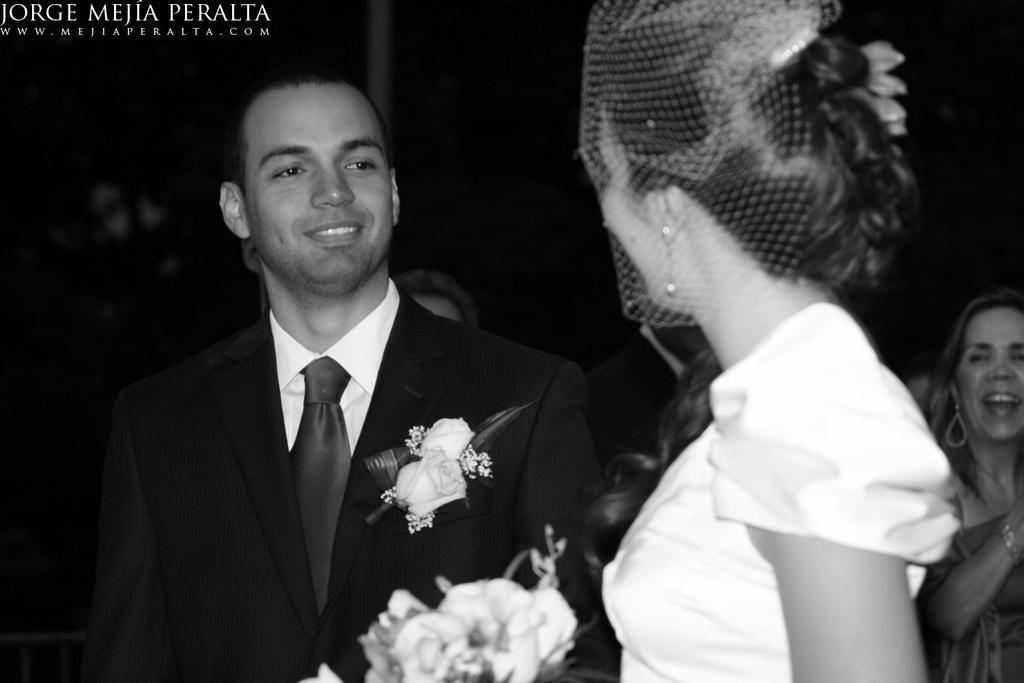In one or two sentences, can you explain what this image depicts? In this picture we can see a man(groom) and a woman(bride). There is a flower bouquet. We can see a few people in the background. A watermark is visible in the top left. 